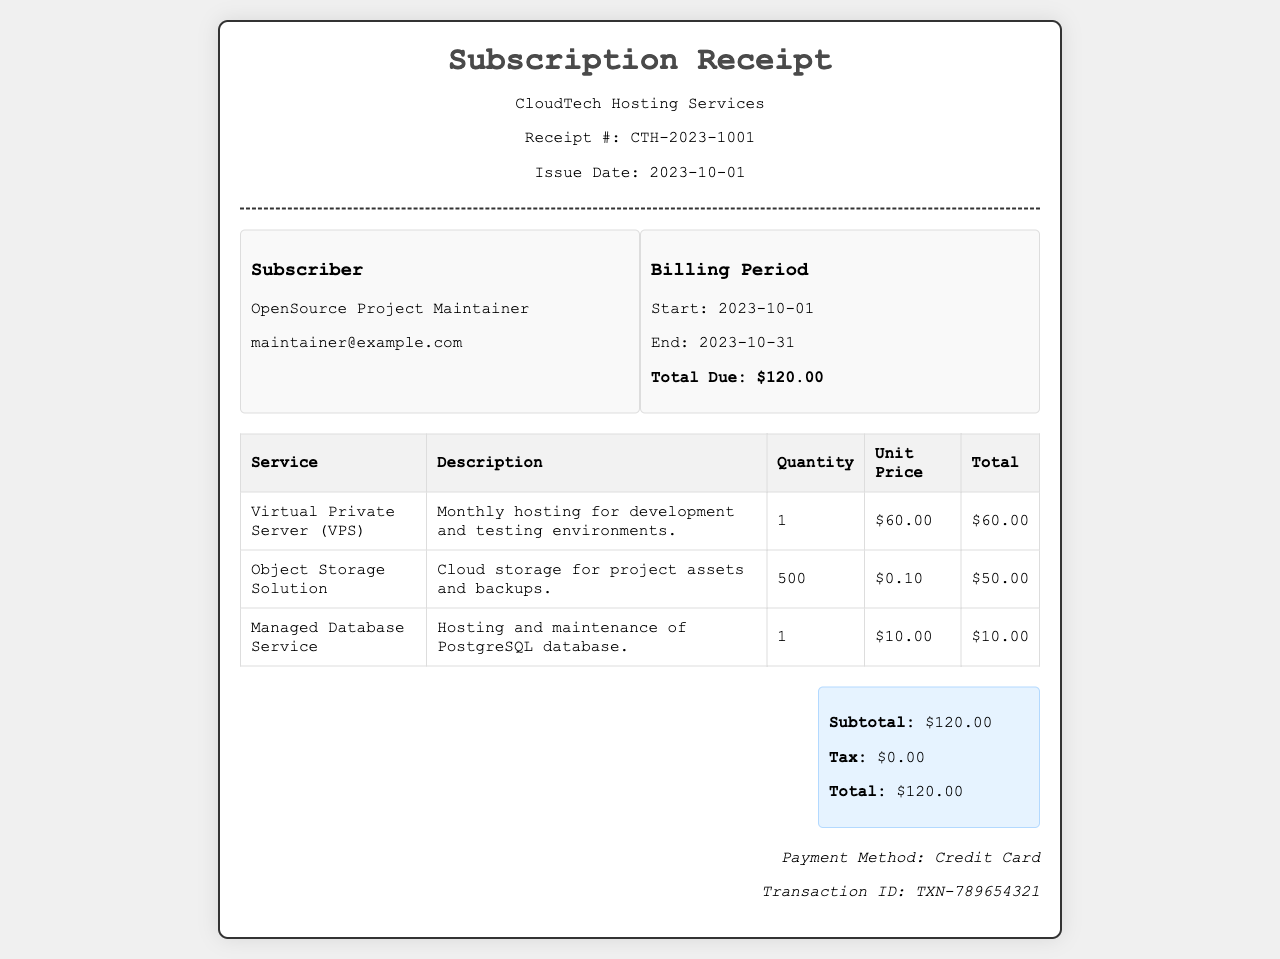What is the receipt number? The receipt number is clearly stated in the document under "Receipt #".
Answer: CTH-2023-1001 What is the issued date of the receipt? The issued date is mentioned just below the receipt number.
Answer: 2023-10-01 What is the total amount due for the billing period? The total amount due is highlighted in the billing period section.
Answer: $120.00 How many services are listed in the receipt? The number of services can be counted in the services table.
Answer: 3 What is the unit price of the Object Storage Solution? The unit price is specified in the services table for the Object Storage Solution.
Answer: $0.10 What is the description of the Managed Database Service? The description for each service is provided in the services table.
Answer: Hosting and maintenance of PostgreSQL database How many units of Object Storage Solution are billed? The quantity for the Object Storage Solution is provided in the services table.
Answer: 500 What payment method was used? The payment method can be found in the payment information at the bottom of the receipt.
Answer: Credit Card What is the subtotal before tax? The subtotal is mentioned in the summary box of the receipt.
Answer: $120.00 